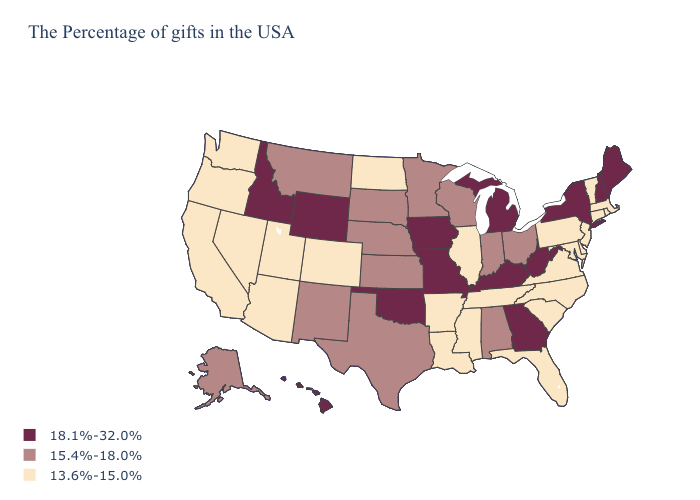Does the first symbol in the legend represent the smallest category?
Short answer required. No. Does Montana have the highest value in the West?
Write a very short answer. No. Name the states that have a value in the range 18.1%-32.0%?
Keep it brief. Maine, New Hampshire, New York, West Virginia, Georgia, Michigan, Kentucky, Missouri, Iowa, Oklahoma, Wyoming, Idaho, Hawaii. Which states have the lowest value in the MidWest?
Short answer required. Illinois, North Dakota. Name the states that have a value in the range 15.4%-18.0%?
Be succinct. Ohio, Indiana, Alabama, Wisconsin, Minnesota, Kansas, Nebraska, Texas, South Dakota, New Mexico, Montana, Alaska. What is the highest value in the USA?
Be succinct. 18.1%-32.0%. What is the value of Colorado?
Concise answer only. 13.6%-15.0%. Which states have the lowest value in the USA?
Keep it brief. Massachusetts, Rhode Island, Vermont, Connecticut, New Jersey, Delaware, Maryland, Pennsylvania, Virginia, North Carolina, South Carolina, Florida, Tennessee, Illinois, Mississippi, Louisiana, Arkansas, North Dakota, Colorado, Utah, Arizona, Nevada, California, Washington, Oregon. Which states have the lowest value in the USA?
Be succinct. Massachusetts, Rhode Island, Vermont, Connecticut, New Jersey, Delaware, Maryland, Pennsylvania, Virginia, North Carolina, South Carolina, Florida, Tennessee, Illinois, Mississippi, Louisiana, Arkansas, North Dakota, Colorado, Utah, Arizona, Nevada, California, Washington, Oregon. Which states hav the highest value in the West?
Quick response, please. Wyoming, Idaho, Hawaii. Which states have the lowest value in the USA?
Short answer required. Massachusetts, Rhode Island, Vermont, Connecticut, New Jersey, Delaware, Maryland, Pennsylvania, Virginia, North Carolina, South Carolina, Florida, Tennessee, Illinois, Mississippi, Louisiana, Arkansas, North Dakota, Colorado, Utah, Arizona, Nevada, California, Washington, Oregon. Among the states that border Mississippi , does Louisiana have the lowest value?
Concise answer only. Yes. What is the highest value in states that border Indiana?
Keep it brief. 18.1%-32.0%. Name the states that have a value in the range 18.1%-32.0%?
Keep it brief. Maine, New Hampshire, New York, West Virginia, Georgia, Michigan, Kentucky, Missouri, Iowa, Oklahoma, Wyoming, Idaho, Hawaii. What is the value of Montana?
Short answer required. 15.4%-18.0%. 